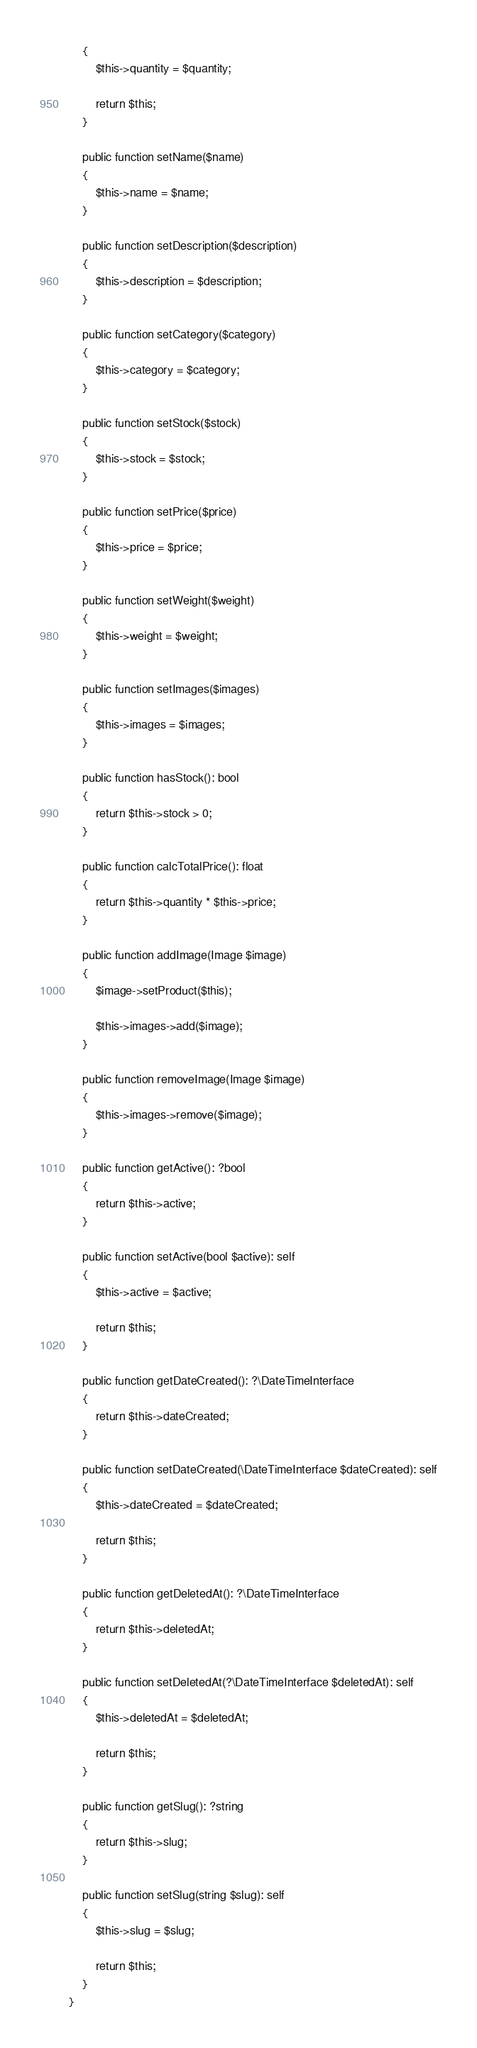Convert code to text. <code><loc_0><loc_0><loc_500><loc_500><_PHP_>    {
        $this->quantity = $quantity;

        return $this;
    }

    public function setName($name)
    {
        $this->name = $name;
    }

    public function setDescription($description)
    {
        $this->description = $description;
    }

    public function setCategory($category)
    {
        $this->category = $category;
    }

    public function setStock($stock)
    {
        $this->stock = $stock;
    }

    public function setPrice($price)
    {
        $this->price = $price;
    }

    public function setWeight($weight)
    {
        $this->weight = $weight;
    }

    public function setImages($images)
    {
        $this->images = $images;
    }

    public function hasStock(): bool
    {
        return $this->stock > 0;
    }
    
    public function calcTotalPrice(): float
    {
        return $this->quantity * $this->price;
    }

    public function addImage(Image $image)
    {
        $image->setProduct($this);
        
        $this->images->add($image);
    }

    public function removeImage(Image $image)
    {
        $this->images->remove($image);
    }

    public function getActive(): ?bool
    {
        return $this->active;
    }

    public function setActive(bool $active): self
    {
        $this->active = $active;

        return $this;
    }

    public function getDateCreated(): ?\DateTimeInterface
    {
        return $this->dateCreated;
    }

    public function setDateCreated(\DateTimeInterface $dateCreated): self
    {
        $this->dateCreated = $dateCreated;

        return $this;
    }

    public function getDeletedAt(): ?\DateTimeInterface
    {
        return $this->deletedAt;
    }

    public function setDeletedAt(?\DateTimeInterface $deletedAt): self
    {
        $this->deletedAt = $deletedAt;

        return $this;
    }

    public function getSlug(): ?string
    {
        return $this->slug;
    }

    public function setSlug(string $slug): self
    {
        $this->slug = $slug;

        return $this;
    }
}
</code> 